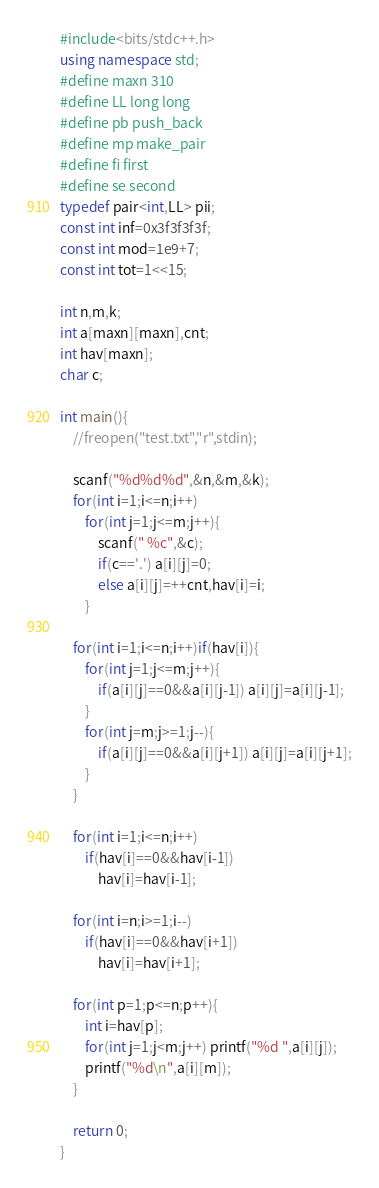<code> <loc_0><loc_0><loc_500><loc_500><_C++_>#include<bits/stdc++.h>
using namespace std;
#define maxn 310
#define LL long long
#define pb push_back
#define mp make_pair
#define fi first
#define se second
typedef pair<int,LL> pii;
const int inf=0x3f3f3f3f;
const int mod=1e9+7;
const int tot=1<<15;

int n,m,k;
int a[maxn][maxn],cnt;
int hav[maxn];
char c;

int main(){
	//freopen("test.txt","r",stdin);
	
	scanf("%d%d%d",&n,&m,&k);
	for(int i=1;i<=n;i++)
		for(int j=1;j<=m;j++){
			scanf(" %c",&c);
			if(c=='.') a[i][j]=0;
			else a[i][j]=++cnt,hav[i]=i;
		}
	
	for(int i=1;i<=n;i++)if(hav[i]){
		for(int j=1;j<=m;j++){
			if(a[i][j]==0&&a[i][j-1]) a[i][j]=a[i][j-1];
		}
		for(int j=m;j>=1;j--){
			if(a[i][j]==0&&a[i][j+1]) a[i][j]=a[i][j+1];
		}
	}
	
	for(int i=1;i<=n;i++)
		if(hav[i]==0&&hav[i-1])
			hav[i]=hav[i-1];
			
	for(int i=n;i>=1;i--)
		if(hav[i]==0&&hav[i+1])
			hav[i]=hav[i+1];
	
	for(int p=1;p<=n;p++){
		int i=hav[p];
		for(int j=1;j<m;j++) printf("%d ",a[i][j]);
		printf("%d\n",a[i][m]);
	}	
	
	return 0;
} </code> 